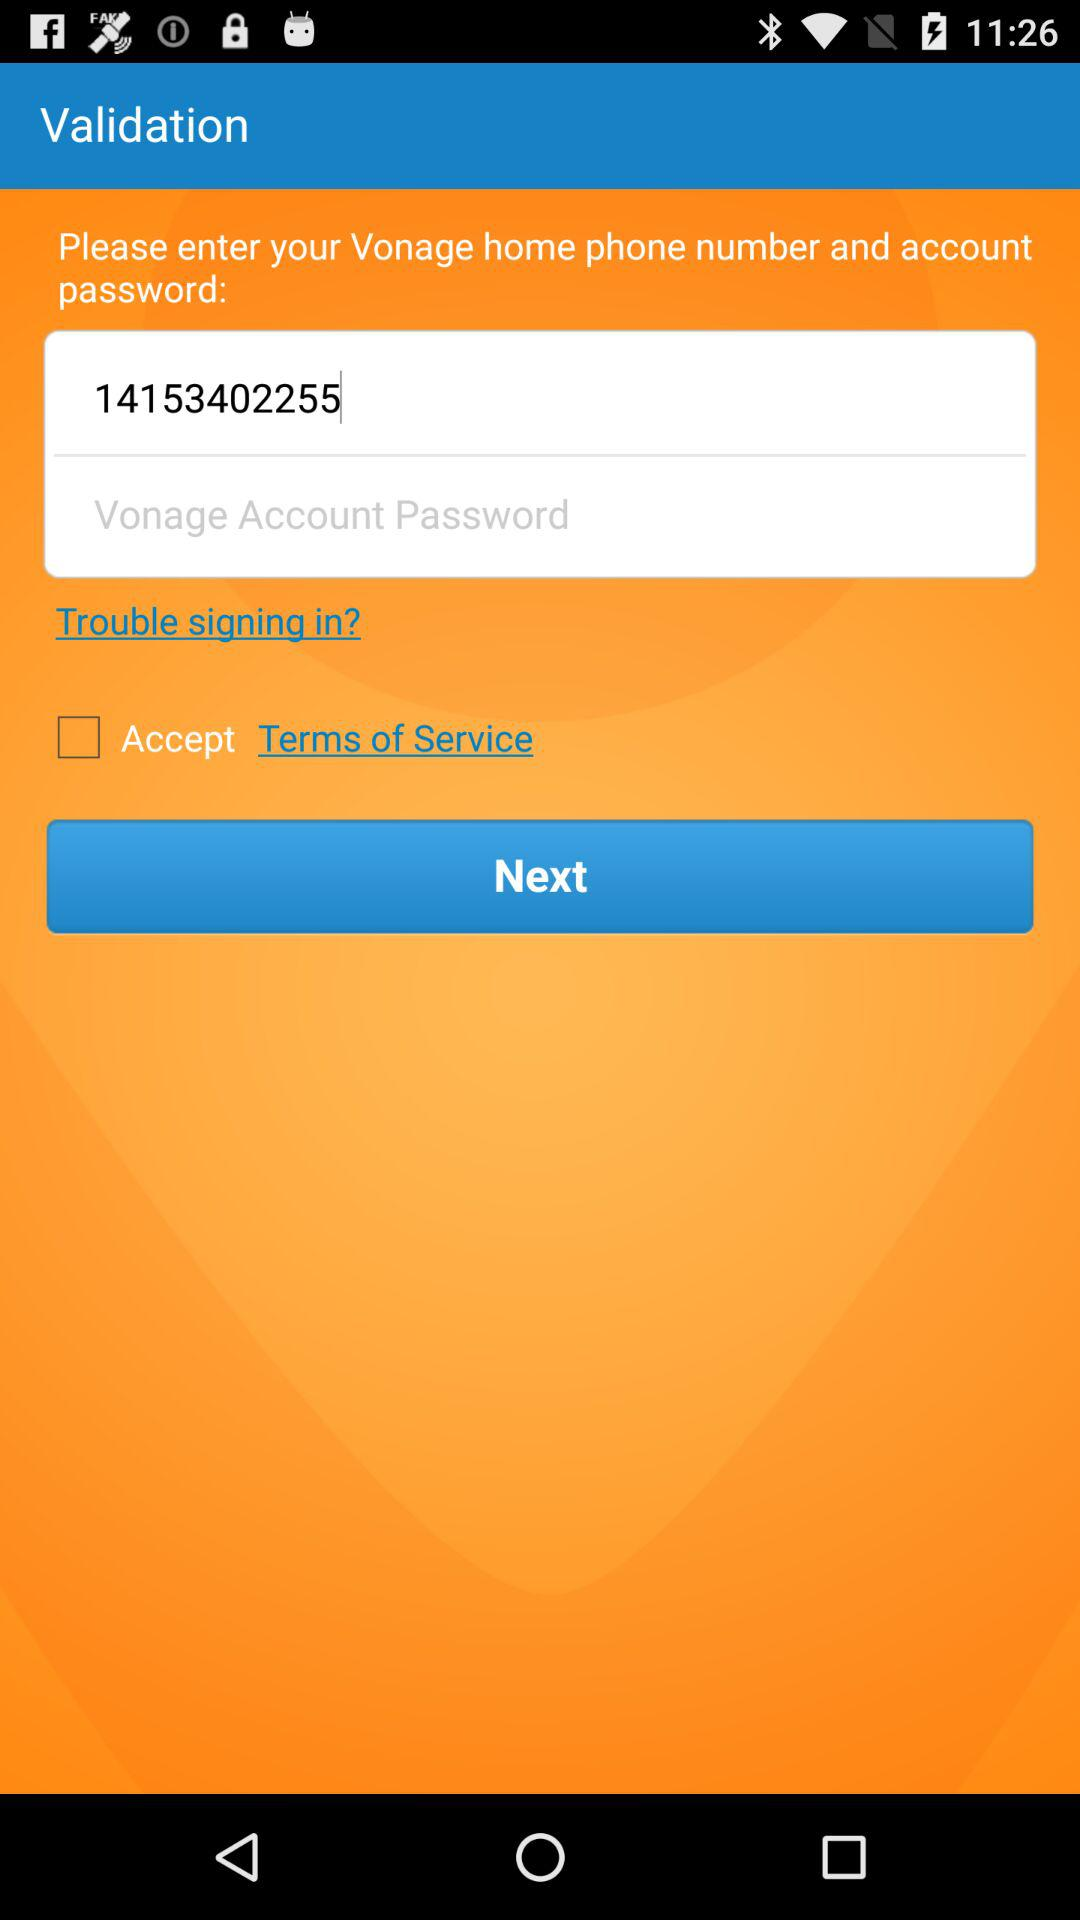What is the phone number given? The given phone number is 14153402255. 